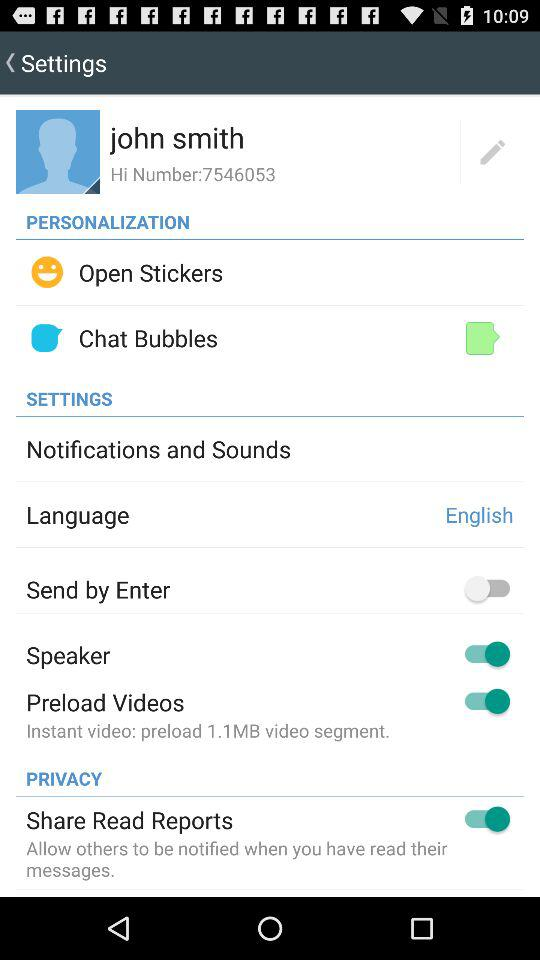What is the login name? The login name is John Smith. 